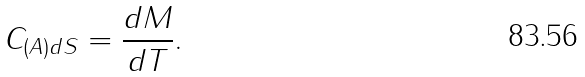<formula> <loc_0><loc_0><loc_500><loc_500>C _ { ( A ) d S } = \frac { d M } { d T } .</formula> 